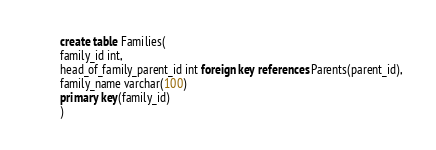Convert code to text. <code><loc_0><loc_0><loc_500><loc_500><_SQL_>create table Families(
family_id int,
head_of_family_parent_id int foreign key references Parents(parent_id),
family_name varchar(100)
primary key(family_id)
)</code> 